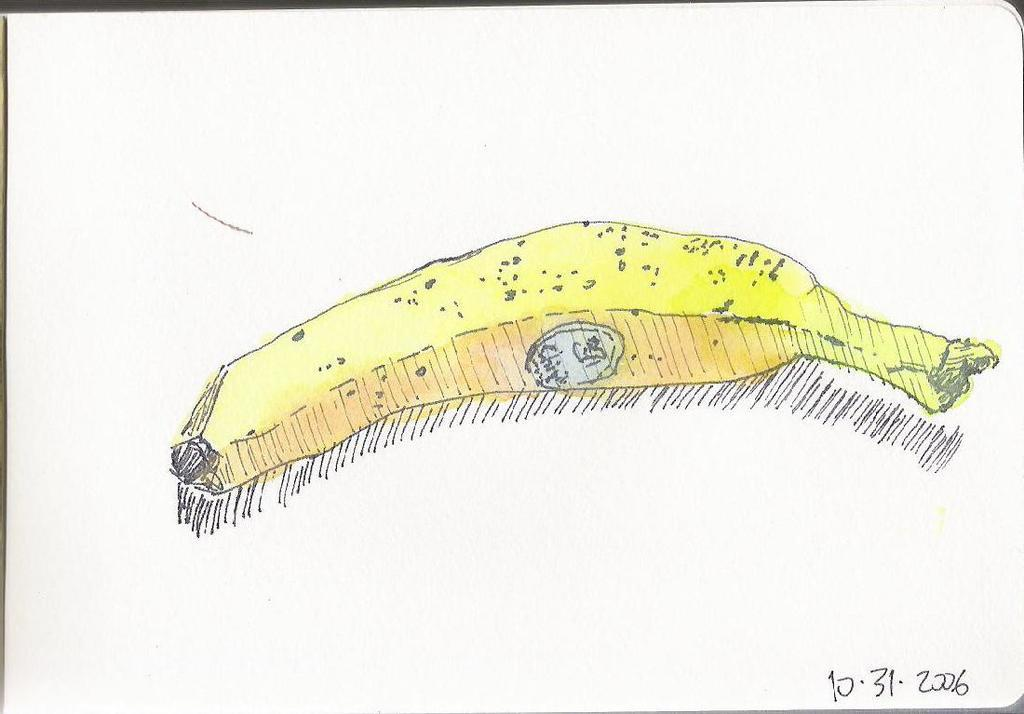What is the main subject of the sketch in the image? The main subject of the sketch in the image is a banana. What can be seen below the sketch? There are lines below the sketch. What information is provided in the bottom right of the image? There are numbers in the bottom right of the image. What color is the background of the image? The background of the image is white. What type of receipt can be seen in the image? There is no receipt present in the image; it features a sketch of a banana with lines and numbers. Can you tell me how many firemen are visible in the image? There are no firemen present in the image. 